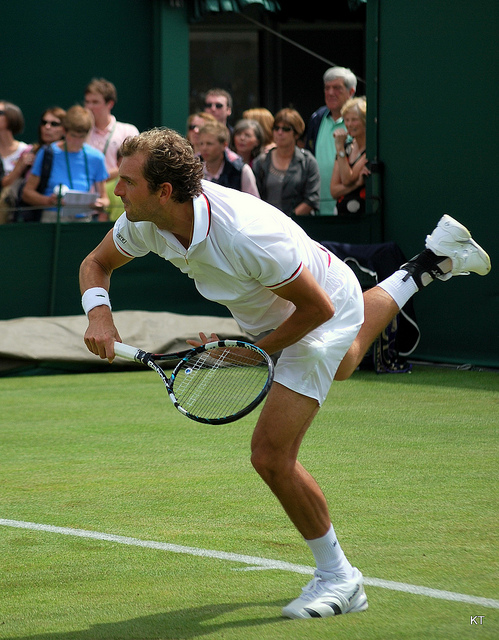Please identify all text content in this image. KT 